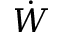Convert formula to latex. <formula><loc_0><loc_0><loc_500><loc_500>\dot { W }</formula> 